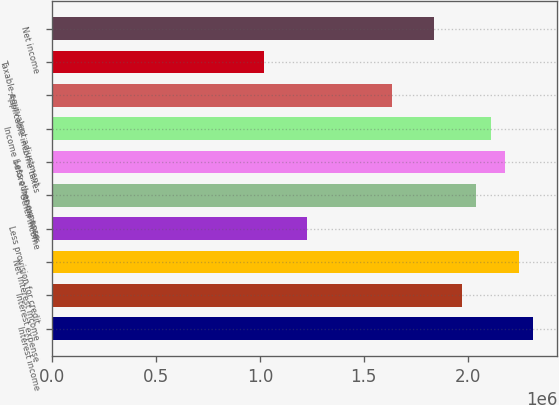<chart> <loc_0><loc_0><loc_500><loc_500><bar_chart><fcel>Interest income<fcel>Interest expense<fcel>Net interest income<fcel>Less provision for credit<fcel>Other income<fcel>Less other expense<fcel>Income before income taxes<fcel>Applicable income taxes<fcel>Taxable-equivalent adjustment<fcel>Net income<nl><fcel>2.31465e+06<fcel>1.97426e+06<fcel>2.24658e+06<fcel>1.22541e+06<fcel>2.04234e+06<fcel>2.1785e+06<fcel>2.11042e+06<fcel>1.63387e+06<fcel>1.02117e+06<fcel>1.83811e+06<nl></chart> 